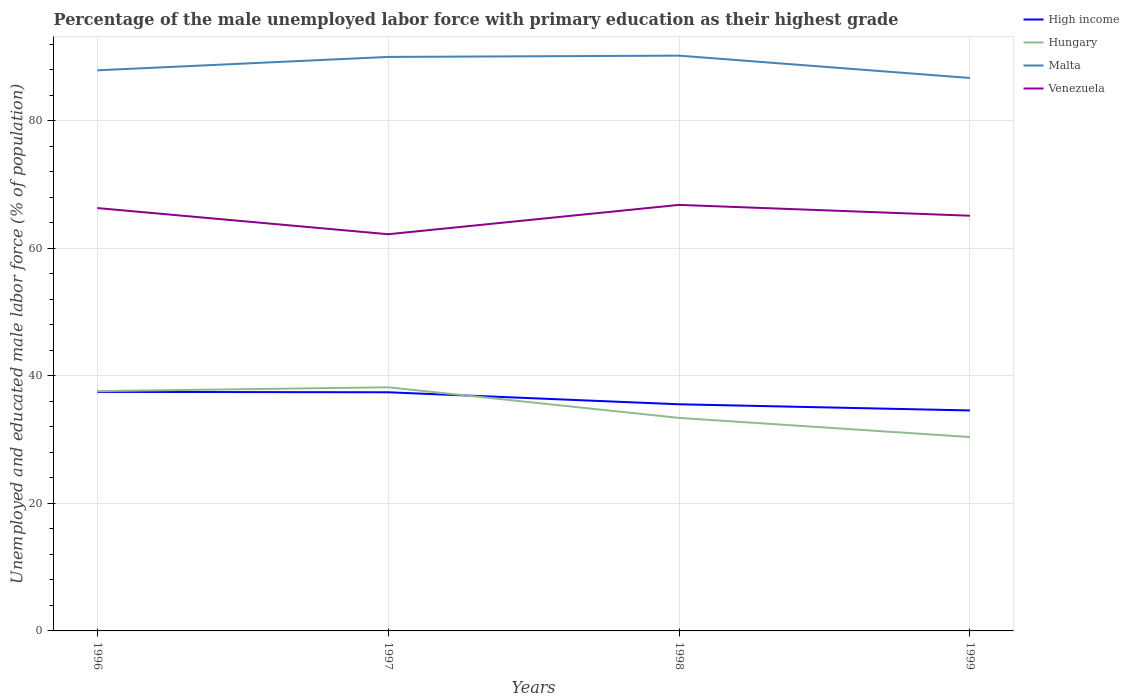Is the number of lines equal to the number of legend labels?
Keep it short and to the point. Yes. Across all years, what is the maximum percentage of the unemployed male labor force with primary education in High income?
Ensure brevity in your answer.  34.57. In which year was the percentage of the unemployed male labor force with primary education in Venezuela maximum?
Offer a very short reply. 1997. What is the total percentage of the unemployed male labor force with primary education in High income in the graph?
Ensure brevity in your answer.  0.06. What is the difference between the highest and the second highest percentage of the unemployed male labor force with primary education in High income?
Make the answer very short. 2.91. What is the difference between the highest and the lowest percentage of the unemployed male labor force with primary education in Hungary?
Ensure brevity in your answer.  2. How many lines are there?
Provide a succinct answer. 4. What is the difference between two consecutive major ticks on the Y-axis?
Your answer should be very brief. 20. Does the graph contain grids?
Your answer should be very brief. Yes. Where does the legend appear in the graph?
Keep it short and to the point. Top right. What is the title of the graph?
Provide a succinct answer. Percentage of the male unemployed labor force with primary education as their highest grade. What is the label or title of the Y-axis?
Ensure brevity in your answer.  Unemployed and educated male labor force (% of population). What is the Unemployed and educated male labor force (% of population) in High income in 1996?
Keep it short and to the point. 37.48. What is the Unemployed and educated male labor force (% of population) of Hungary in 1996?
Make the answer very short. 37.6. What is the Unemployed and educated male labor force (% of population) of Malta in 1996?
Give a very brief answer. 87.9. What is the Unemployed and educated male labor force (% of population) of Venezuela in 1996?
Provide a succinct answer. 66.3. What is the Unemployed and educated male labor force (% of population) of High income in 1997?
Provide a succinct answer. 37.42. What is the Unemployed and educated male labor force (% of population) in Hungary in 1997?
Your response must be concise. 38.2. What is the Unemployed and educated male labor force (% of population) in Venezuela in 1997?
Give a very brief answer. 62.2. What is the Unemployed and educated male labor force (% of population) of High income in 1998?
Your answer should be very brief. 35.54. What is the Unemployed and educated male labor force (% of population) of Hungary in 1998?
Provide a short and direct response. 33.4. What is the Unemployed and educated male labor force (% of population) in Malta in 1998?
Your answer should be compact. 90.2. What is the Unemployed and educated male labor force (% of population) of Venezuela in 1998?
Provide a succinct answer. 66.8. What is the Unemployed and educated male labor force (% of population) in High income in 1999?
Provide a succinct answer. 34.57. What is the Unemployed and educated male labor force (% of population) of Hungary in 1999?
Give a very brief answer. 30.4. What is the Unemployed and educated male labor force (% of population) in Malta in 1999?
Ensure brevity in your answer.  86.7. What is the Unemployed and educated male labor force (% of population) of Venezuela in 1999?
Give a very brief answer. 65.1. Across all years, what is the maximum Unemployed and educated male labor force (% of population) of High income?
Offer a terse response. 37.48. Across all years, what is the maximum Unemployed and educated male labor force (% of population) of Hungary?
Make the answer very short. 38.2. Across all years, what is the maximum Unemployed and educated male labor force (% of population) of Malta?
Your answer should be very brief. 90.2. Across all years, what is the maximum Unemployed and educated male labor force (% of population) in Venezuela?
Give a very brief answer. 66.8. Across all years, what is the minimum Unemployed and educated male labor force (% of population) in High income?
Your answer should be compact. 34.57. Across all years, what is the minimum Unemployed and educated male labor force (% of population) of Hungary?
Provide a short and direct response. 30.4. Across all years, what is the minimum Unemployed and educated male labor force (% of population) in Malta?
Your response must be concise. 86.7. Across all years, what is the minimum Unemployed and educated male labor force (% of population) in Venezuela?
Provide a short and direct response. 62.2. What is the total Unemployed and educated male labor force (% of population) in High income in the graph?
Ensure brevity in your answer.  145. What is the total Unemployed and educated male labor force (% of population) of Hungary in the graph?
Provide a short and direct response. 139.6. What is the total Unemployed and educated male labor force (% of population) of Malta in the graph?
Your answer should be very brief. 354.8. What is the total Unemployed and educated male labor force (% of population) in Venezuela in the graph?
Provide a short and direct response. 260.4. What is the difference between the Unemployed and educated male labor force (% of population) in High income in 1996 and that in 1997?
Ensure brevity in your answer.  0.06. What is the difference between the Unemployed and educated male labor force (% of population) of Hungary in 1996 and that in 1997?
Keep it short and to the point. -0.6. What is the difference between the Unemployed and educated male labor force (% of population) of Malta in 1996 and that in 1997?
Ensure brevity in your answer.  -2.1. What is the difference between the Unemployed and educated male labor force (% of population) in High income in 1996 and that in 1998?
Your answer should be very brief. 1.94. What is the difference between the Unemployed and educated male labor force (% of population) in High income in 1996 and that in 1999?
Your response must be concise. 2.91. What is the difference between the Unemployed and educated male labor force (% of population) in Malta in 1996 and that in 1999?
Ensure brevity in your answer.  1.2. What is the difference between the Unemployed and educated male labor force (% of population) in High income in 1997 and that in 1998?
Your answer should be compact. 1.88. What is the difference between the Unemployed and educated male labor force (% of population) of Hungary in 1997 and that in 1998?
Make the answer very short. 4.8. What is the difference between the Unemployed and educated male labor force (% of population) of Malta in 1997 and that in 1998?
Give a very brief answer. -0.2. What is the difference between the Unemployed and educated male labor force (% of population) of High income in 1997 and that in 1999?
Provide a short and direct response. 2.85. What is the difference between the Unemployed and educated male labor force (% of population) in Hungary in 1997 and that in 1999?
Keep it short and to the point. 7.8. What is the difference between the Unemployed and educated male labor force (% of population) of Malta in 1997 and that in 1999?
Give a very brief answer. 3.3. What is the difference between the Unemployed and educated male labor force (% of population) of High income in 1998 and that in 1999?
Ensure brevity in your answer.  0.97. What is the difference between the Unemployed and educated male labor force (% of population) in Hungary in 1998 and that in 1999?
Make the answer very short. 3. What is the difference between the Unemployed and educated male labor force (% of population) in Malta in 1998 and that in 1999?
Provide a short and direct response. 3.5. What is the difference between the Unemployed and educated male labor force (% of population) in High income in 1996 and the Unemployed and educated male labor force (% of population) in Hungary in 1997?
Your answer should be compact. -0.72. What is the difference between the Unemployed and educated male labor force (% of population) of High income in 1996 and the Unemployed and educated male labor force (% of population) of Malta in 1997?
Provide a succinct answer. -52.52. What is the difference between the Unemployed and educated male labor force (% of population) of High income in 1996 and the Unemployed and educated male labor force (% of population) of Venezuela in 1997?
Give a very brief answer. -24.72. What is the difference between the Unemployed and educated male labor force (% of population) in Hungary in 1996 and the Unemployed and educated male labor force (% of population) in Malta in 1997?
Keep it short and to the point. -52.4. What is the difference between the Unemployed and educated male labor force (% of population) of Hungary in 1996 and the Unemployed and educated male labor force (% of population) of Venezuela in 1997?
Provide a succinct answer. -24.6. What is the difference between the Unemployed and educated male labor force (% of population) of Malta in 1996 and the Unemployed and educated male labor force (% of population) of Venezuela in 1997?
Your answer should be very brief. 25.7. What is the difference between the Unemployed and educated male labor force (% of population) in High income in 1996 and the Unemployed and educated male labor force (% of population) in Hungary in 1998?
Offer a terse response. 4.08. What is the difference between the Unemployed and educated male labor force (% of population) in High income in 1996 and the Unemployed and educated male labor force (% of population) in Malta in 1998?
Offer a terse response. -52.72. What is the difference between the Unemployed and educated male labor force (% of population) of High income in 1996 and the Unemployed and educated male labor force (% of population) of Venezuela in 1998?
Ensure brevity in your answer.  -29.32. What is the difference between the Unemployed and educated male labor force (% of population) of Hungary in 1996 and the Unemployed and educated male labor force (% of population) of Malta in 1998?
Provide a succinct answer. -52.6. What is the difference between the Unemployed and educated male labor force (% of population) in Hungary in 1996 and the Unemployed and educated male labor force (% of population) in Venezuela in 1998?
Offer a terse response. -29.2. What is the difference between the Unemployed and educated male labor force (% of population) in Malta in 1996 and the Unemployed and educated male labor force (% of population) in Venezuela in 1998?
Ensure brevity in your answer.  21.1. What is the difference between the Unemployed and educated male labor force (% of population) of High income in 1996 and the Unemployed and educated male labor force (% of population) of Hungary in 1999?
Provide a succinct answer. 7.08. What is the difference between the Unemployed and educated male labor force (% of population) in High income in 1996 and the Unemployed and educated male labor force (% of population) in Malta in 1999?
Provide a short and direct response. -49.22. What is the difference between the Unemployed and educated male labor force (% of population) of High income in 1996 and the Unemployed and educated male labor force (% of population) of Venezuela in 1999?
Ensure brevity in your answer.  -27.62. What is the difference between the Unemployed and educated male labor force (% of population) of Hungary in 1996 and the Unemployed and educated male labor force (% of population) of Malta in 1999?
Your answer should be compact. -49.1. What is the difference between the Unemployed and educated male labor force (% of population) of Hungary in 1996 and the Unemployed and educated male labor force (% of population) of Venezuela in 1999?
Offer a very short reply. -27.5. What is the difference between the Unemployed and educated male labor force (% of population) of Malta in 1996 and the Unemployed and educated male labor force (% of population) of Venezuela in 1999?
Make the answer very short. 22.8. What is the difference between the Unemployed and educated male labor force (% of population) in High income in 1997 and the Unemployed and educated male labor force (% of population) in Hungary in 1998?
Your answer should be very brief. 4.02. What is the difference between the Unemployed and educated male labor force (% of population) in High income in 1997 and the Unemployed and educated male labor force (% of population) in Malta in 1998?
Keep it short and to the point. -52.78. What is the difference between the Unemployed and educated male labor force (% of population) in High income in 1997 and the Unemployed and educated male labor force (% of population) in Venezuela in 1998?
Offer a very short reply. -29.38. What is the difference between the Unemployed and educated male labor force (% of population) in Hungary in 1997 and the Unemployed and educated male labor force (% of population) in Malta in 1998?
Provide a succinct answer. -52. What is the difference between the Unemployed and educated male labor force (% of population) of Hungary in 1997 and the Unemployed and educated male labor force (% of population) of Venezuela in 1998?
Keep it short and to the point. -28.6. What is the difference between the Unemployed and educated male labor force (% of population) of Malta in 1997 and the Unemployed and educated male labor force (% of population) of Venezuela in 1998?
Offer a terse response. 23.2. What is the difference between the Unemployed and educated male labor force (% of population) in High income in 1997 and the Unemployed and educated male labor force (% of population) in Hungary in 1999?
Make the answer very short. 7.02. What is the difference between the Unemployed and educated male labor force (% of population) of High income in 1997 and the Unemployed and educated male labor force (% of population) of Malta in 1999?
Keep it short and to the point. -49.28. What is the difference between the Unemployed and educated male labor force (% of population) of High income in 1997 and the Unemployed and educated male labor force (% of population) of Venezuela in 1999?
Your answer should be compact. -27.68. What is the difference between the Unemployed and educated male labor force (% of population) in Hungary in 1997 and the Unemployed and educated male labor force (% of population) in Malta in 1999?
Your answer should be very brief. -48.5. What is the difference between the Unemployed and educated male labor force (% of population) in Hungary in 1997 and the Unemployed and educated male labor force (% of population) in Venezuela in 1999?
Your answer should be compact. -26.9. What is the difference between the Unemployed and educated male labor force (% of population) of Malta in 1997 and the Unemployed and educated male labor force (% of population) of Venezuela in 1999?
Ensure brevity in your answer.  24.9. What is the difference between the Unemployed and educated male labor force (% of population) of High income in 1998 and the Unemployed and educated male labor force (% of population) of Hungary in 1999?
Your answer should be compact. 5.14. What is the difference between the Unemployed and educated male labor force (% of population) in High income in 1998 and the Unemployed and educated male labor force (% of population) in Malta in 1999?
Provide a short and direct response. -51.16. What is the difference between the Unemployed and educated male labor force (% of population) of High income in 1998 and the Unemployed and educated male labor force (% of population) of Venezuela in 1999?
Your response must be concise. -29.56. What is the difference between the Unemployed and educated male labor force (% of population) of Hungary in 1998 and the Unemployed and educated male labor force (% of population) of Malta in 1999?
Offer a very short reply. -53.3. What is the difference between the Unemployed and educated male labor force (% of population) of Hungary in 1998 and the Unemployed and educated male labor force (% of population) of Venezuela in 1999?
Ensure brevity in your answer.  -31.7. What is the difference between the Unemployed and educated male labor force (% of population) in Malta in 1998 and the Unemployed and educated male labor force (% of population) in Venezuela in 1999?
Ensure brevity in your answer.  25.1. What is the average Unemployed and educated male labor force (% of population) of High income per year?
Provide a short and direct response. 36.25. What is the average Unemployed and educated male labor force (% of population) in Hungary per year?
Ensure brevity in your answer.  34.9. What is the average Unemployed and educated male labor force (% of population) of Malta per year?
Provide a succinct answer. 88.7. What is the average Unemployed and educated male labor force (% of population) of Venezuela per year?
Ensure brevity in your answer.  65.1. In the year 1996, what is the difference between the Unemployed and educated male labor force (% of population) in High income and Unemployed and educated male labor force (% of population) in Hungary?
Offer a terse response. -0.12. In the year 1996, what is the difference between the Unemployed and educated male labor force (% of population) of High income and Unemployed and educated male labor force (% of population) of Malta?
Ensure brevity in your answer.  -50.42. In the year 1996, what is the difference between the Unemployed and educated male labor force (% of population) in High income and Unemployed and educated male labor force (% of population) in Venezuela?
Offer a terse response. -28.82. In the year 1996, what is the difference between the Unemployed and educated male labor force (% of population) of Hungary and Unemployed and educated male labor force (% of population) of Malta?
Keep it short and to the point. -50.3. In the year 1996, what is the difference between the Unemployed and educated male labor force (% of population) of Hungary and Unemployed and educated male labor force (% of population) of Venezuela?
Make the answer very short. -28.7. In the year 1996, what is the difference between the Unemployed and educated male labor force (% of population) in Malta and Unemployed and educated male labor force (% of population) in Venezuela?
Provide a short and direct response. 21.6. In the year 1997, what is the difference between the Unemployed and educated male labor force (% of population) of High income and Unemployed and educated male labor force (% of population) of Hungary?
Keep it short and to the point. -0.78. In the year 1997, what is the difference between the Unemployed and educated male labor force (% of population) of High income and Unemployed and educated male labor force (% of population) of Malta?
Offer a terse response. -52.58. In the year 1997, what is the difference between the Unemployed and educated male labor force (% of population) in High income and Unemployed and educated male labor force (% of population) in Venezuela?
Give a very brief answer. -24.78. In the year 1997, what is the difference between the Unemployed and educated male labor force (% of population) in Hungary and Unemployed and educated male labor force (% of population) in Malta?
Provide a short and direct response. -51.8. In the year 1997, what is the difference between the Unemployed and educated male labor force (% of population) of Malta and Unemployed and educated male labor force (% of population) of Venezuela?
Ensure brevity in your answer.  27.8. In the year 1998, what is the difference between the Unemployed and educated male labor force (% of population) in High income and Unemployed and educated male labor force (% of population) in Hungary?
Keep it short and to the point. 2.14. In the year 1998, what is the difference between the Unemployed and educated male labor force (% of population) of High income and Unemployed and educated male labor force (% of population) of Malta?
Your response must be concise. -54.66. In the year 1998, what is the difference between the Unemployed and educated male labor force (% of population) in High income and Unemployed and educated male labor force (% of population) in Venezuela?
Provide a short and direct response. -31.26. In the year 1998, what is the difference between the Unemployed and educated male labor force (% of population) in Hungary and Unemployed and educated male labor force (% of population) in Malta?
Ensure brevity in your answer.  -56.8. In the year 1998, what is the difference between the Unemployed and educated male labor force (% of population) of Hungary and Unemployed and educated male labor force (% of population) of Venezuela?
Provide a succinct answer. -33.4. In the year 1998, what is the difference between the Unemployed and educated male labor force (% of population) of Malta and Unemployed and educated male labor force (% of population) of Venezuela?
Provide a succinct answer. 23.4. In the year 1999, what is the difference between the Unemployed and educated male labor force (% of population) in High income and Unemployed and educated male labor force (% of population) in Hungary?
Your answer should be very brief. 4.17. In the year 1999, what is the difference between the Unemployed and educated male labor force (% of population) of High income and Unemployed and educated male labor force (% of population) of Malta?
Keep it short and to the point. -52.13. In the year 1999, what is the difference between the Unemployed and educated male labor force (% of population) in High income and Unemployed and educated male labor force (% of population) in Venezuela?
Your answer should be very brief. -30.53. In the year 1999, what is the difference between the Unemployed and educated male labor force (% of population) in Hungary and Unemployed and educated male labor force (% of population) in Malta?
Offer a very short reply. -56.3. In the year 1999, what is the difference between the Unemployed and educated male labor force (% of population) of Hungary and Unemployed and educated male labor force (% of population) of Venezuela?
Provide a succinct answer. -34.7. In the year 1999, what is the difference between the Unemployed and educated male labor force (% of population) in Malta and Unemployed and educated male labor force (% of population) in Venezuela?
Give a very brief answer. 21.6. What is the ratio of the Unemployed and educated male labor force (% of population) in Hungary in 1996 to that in 1997?
Ensure brevity in your answer.  0.98. What is the ratio of the Unemployed and educated male labor force (% of population) in Malta in 1996 to that in 1997?
Give a very brief answer. 0.98. What is the ratio of the Unemployed and educated male labor force (% of population) in Venezuela in 1996 to that in 1997?
Make the answer very short. 1.07. What is the ratio of the Unemployed and educated male labor force (% of population) of High income in 1996 to that in 1998?
Give a very brief answer. 1.05. What is the ratio of the Unemployed and educated male labor force (% of population) of Hungary in 1996 to that in 1998?
Give a very brief answer. 1.13. What is the ratio of the Unemployed and educated male labor force (% of population) of Malta in 1996 to that in 1998?
Give a very brief answer. 0.97. What is the ratio of the Unemployed and educated male labor force (% of population) in High income in 1996 to that in 1999?
Give a very brief answer. 1.08. What is the ratio of the Unemployed and educated male labor force (% of population) of Hungary in 1996 to that in 1999?
Your response must be concise. 1.24. What is the ratio of the Unemployed and educated male labor force (% of population) of Malta in 1996 to that in 1999?
Your answer should be compact. 1.01. What is the ratio of the Unemployed and educated male labor force (% of population) of Venezuela in 1996 to that in 1999?
Your response must be concise. 1.02. What is the ratio of the Unemployed and educated male labor force (% of population) of High income in 1997 to that in 1998?
Provide a short and direct response. 1.05. What is the ratio of the Unemployed and educated male labor force (% of population) of Hungary in 1997 to that in 1998?
Your answer should be very brief. 1.14. What is the ratio of the Unemployed and educated male labor force (% of population) in Malta in 1997 to that in 1998?
Your answer should be very brief. 1. What is the ratio of the Unemployed and educated male labor force (% of population) in Venezuela in 1997 to that in 1998?
Offer a very short reply. 0.93. What is the ratio of the Unemployed and educated male labor force (% of population) in High income in 1997 to that in 1999?
Offer a very short reply. 1.08. What is the ratio of the Unemployed and educated male labor force (% of population) of Hungary in 1997 to that in 1999?
Provide a succinct answer. 1.26. What is the ratio of the Unemployed and educated male labor force (% of population) of Malta in 1997 to that in 1999?
Keep it short and to the point. 1.04. What is the ratio of the Unemployed and educated male labor force (% of population) in Venezuela in 1997 to that in 1999?
Provide a short and direct response. 0.96. What is the ratio of the Unemployed and educated male labor force (% of population) of High income in 1998 to that in 1999?
Offer a very short reply. 1.03. What is the ratio of the Unemployed and educated male labor force (% of population) of Hungary in 1998 to that in 1999?
Your answer should be very brief. 1.1. What is the ratio of the Unemployed and educated male labor force (% of population) in Malta in 1998 to that in 1999?
Give a very brief answer. 1.04. What is the ratio of the Unemployed and educated male labor force (% of population) of Venezuela in 1998 to that in 1999?
Offer a terse response. 1.03. What is the difference between the highest and the second highest Unemployed and educated male labor force (% of population) in High income?
Your response must be concise. 0.06. What is the difference between the highest and the second highest Unemployed and educated male labor force (% of population) in Hungary?
Give a very brief answer. 0.6. What is the difference between the highest and the lowest Unemployed and educated male labor force (% of population) in High income?
Ensure brevity in your answer.  2.91. 